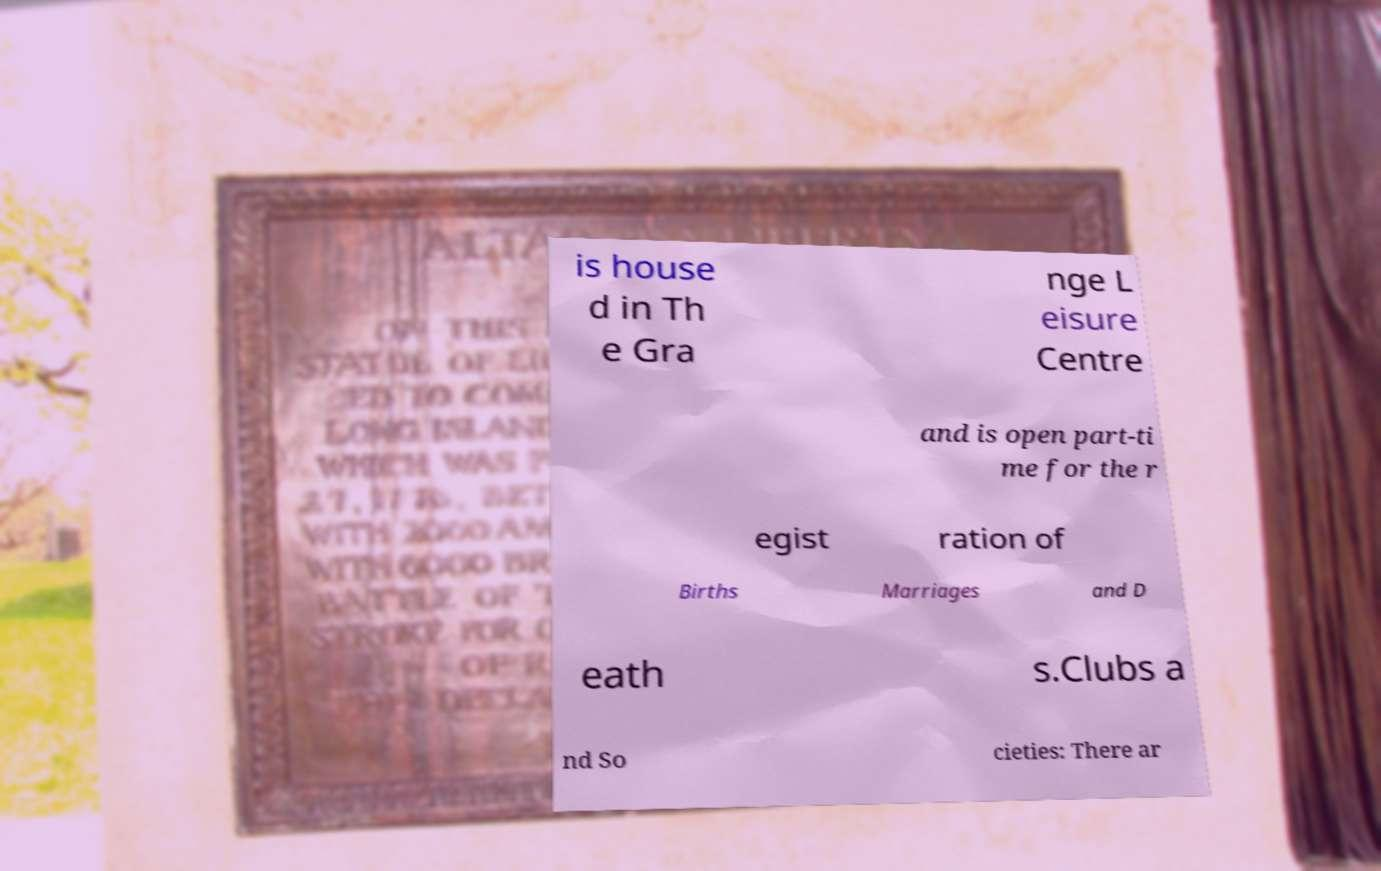What messages or text are displayed in this image? I need them in a readable, typed format. is house d in Th e Gra nge L eisure Centre and is open part-ti me for the r egist ration of Births Marriages and D eath s.Clubs a nd So cieties: There ar 